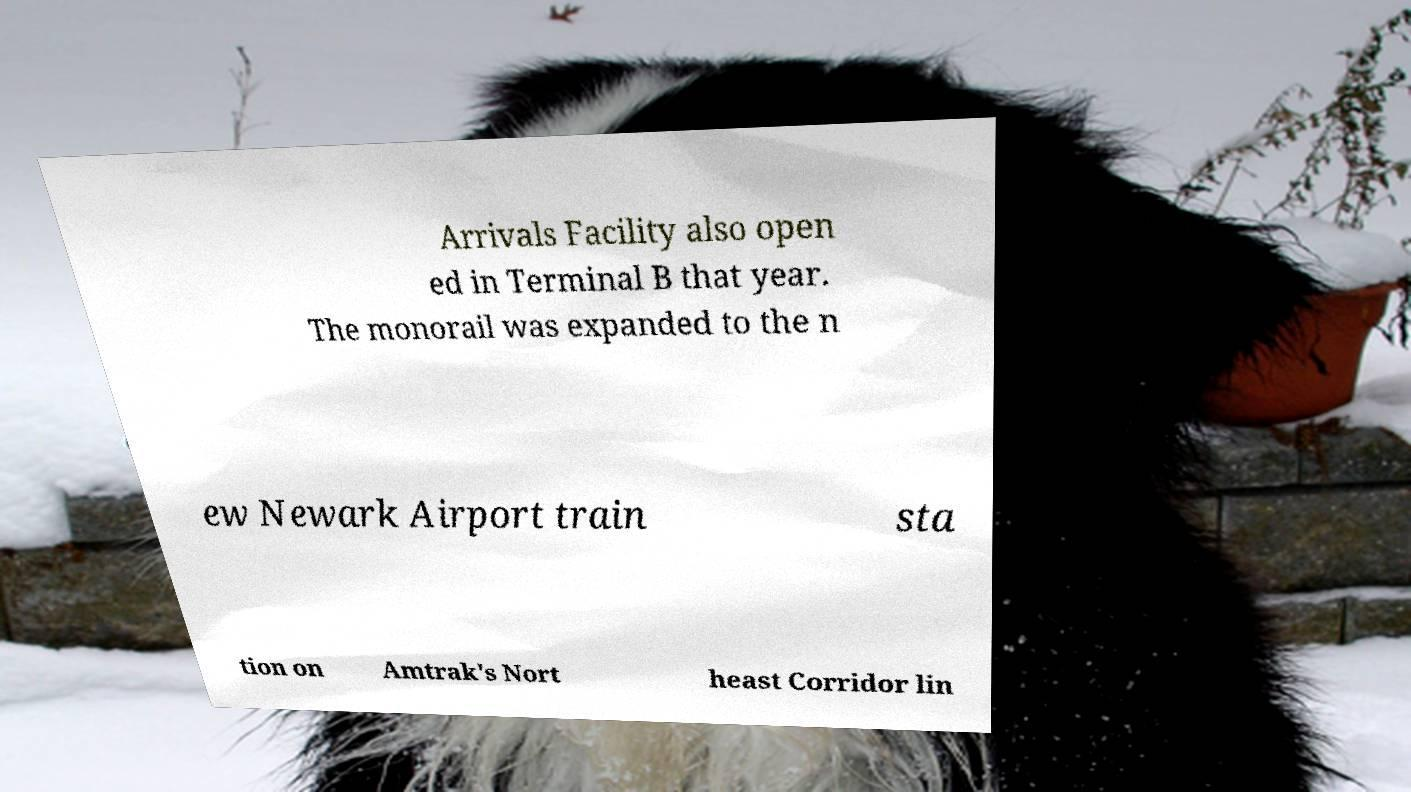Please read and relay the text visible in this image. What does it say? Arrivals Facility also open ed in Terminal B that year. The monorail was expanded to the n ew Newark Airport train sta tion on Amtrak's Nort heast Corridor lin 